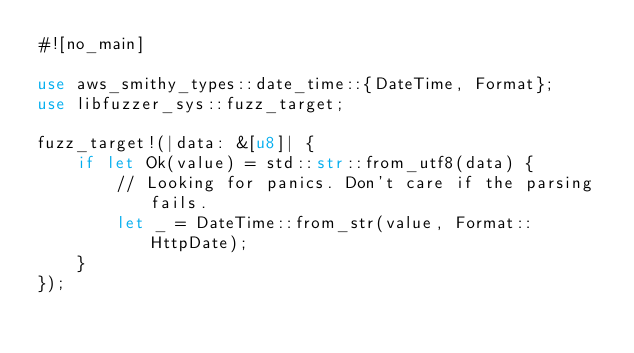Convert code to text. <code><loc_0><loc_0><loc_500><loc_500><_Rust_>#![no_main]

use aws_smithy_types::date_time::{DateTime, Format};
use libfuzzer_sys::fuzz_target;

fuzz_target!(|data: &[u8]| {
    if let Ok(value) = std::str::from_utf8(data) {
        // Looking for panics. Don't care if the parsing fails.
        let _ = DateTime::from_str(value, Format::HttpDate);
    }
});
</code> 